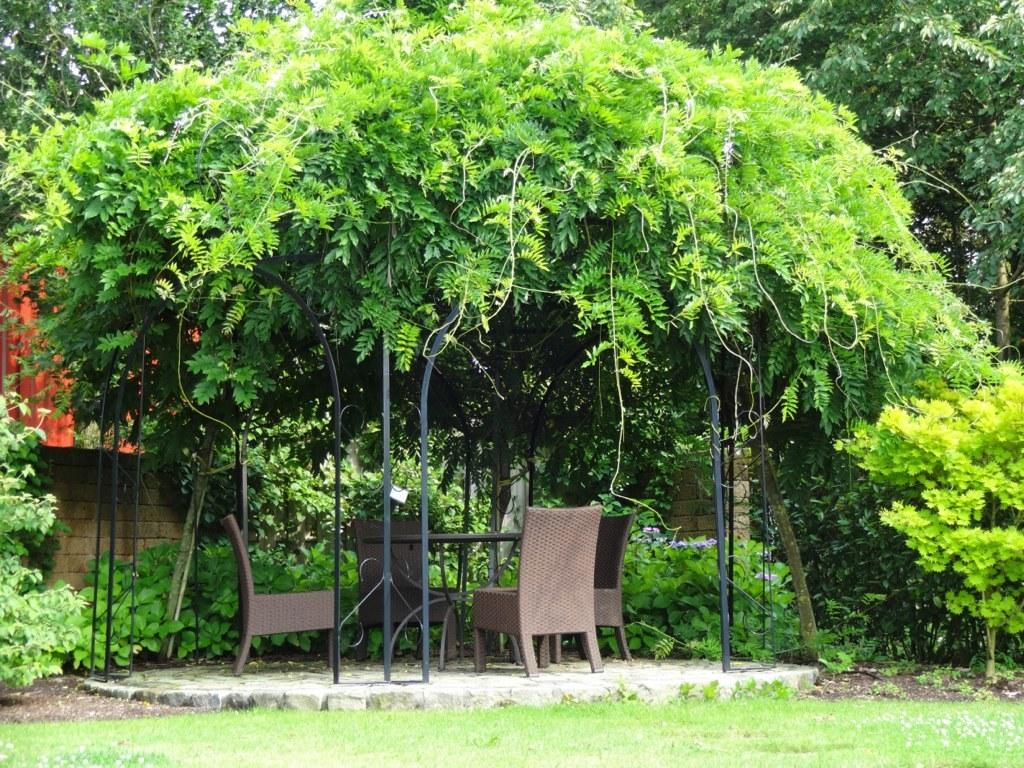What type of furniture can be seen in the image? There are chairs in the image. What other piece of furniture is present in the image? There is a table in the image. What is the ground surface like in the image? There is green grass visible in the image. What can be seen in the background of the image? Trees are present in the background of the image. What architectural feature is visible in the image? There is a wall in the image. What type of ice can be seen melting on the wall in the image? There is no ice present in the image, and therefore no such activity can be observed. What color is the beam that supports the wall in the image? There is no beam mentioned in the provided facts, and the color of any unseen support structure cannot be determined. 